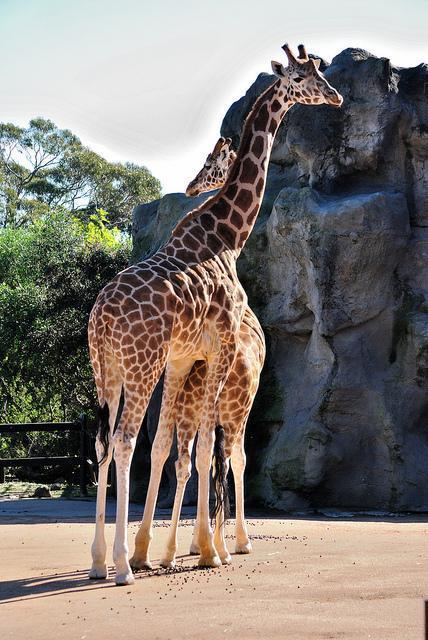How many giraffes are in the photograph?
Give a very brief answer. 2. How many giraffes can you see?
Give a very brief answer. 2. 